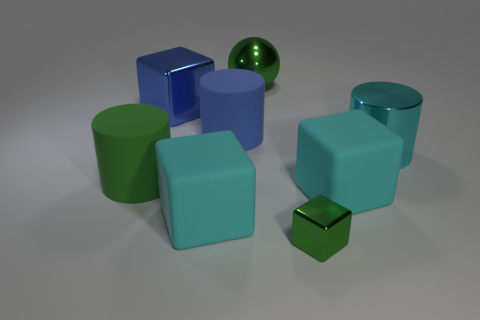Can you tell me about the different shapes and colors present in this image? Certainly! In this image, we see a collection of geometric shapes that include cylinders and cubes. The color palette features green, cyan, and blue primarily. There's a distinct large cyan cylinder, along with a small green sphere, green cylinders, and cubes in various sizes and shades of blue and green. Could you describe the lighting and shadows in the image? The image has a single prominent light source from above that casts soft-edged shadows on the ground behind each shape. The lighting gives the objects a three-dimensional quality and suggests an indoor setting with diffused illumination. 